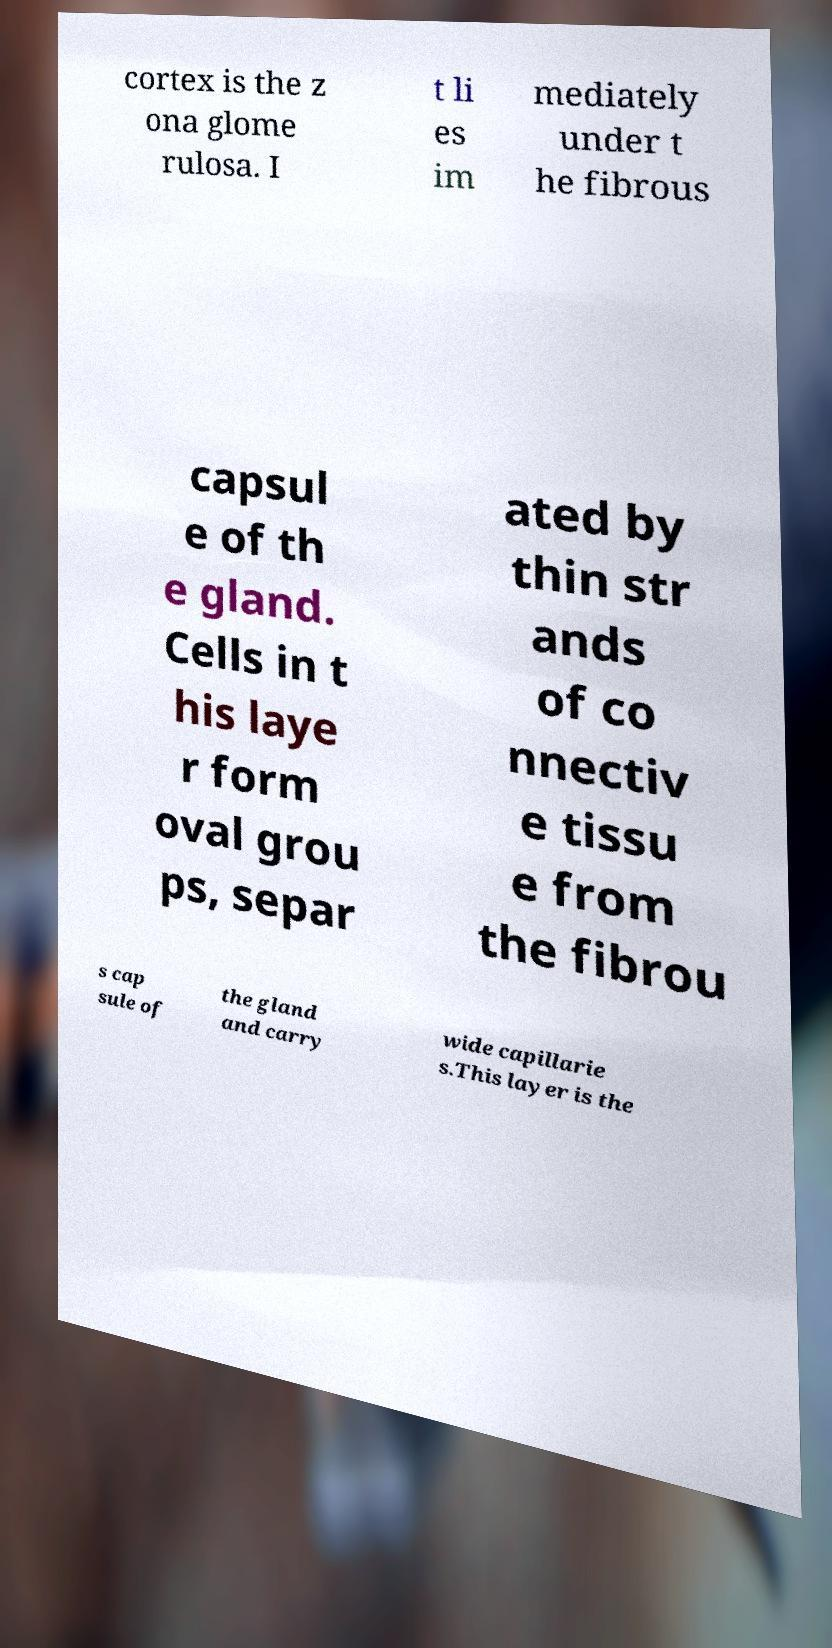There's text embedded in this image that I need extracted. Can you transcribe it verbatim? cortex is the z ona glome rulosa. I t li es im mediately under t he fibrous capsul e of th e gland. Cells in t his laye r form oval grou ps, separ ated by thin str ands of co nnectiv e tissu e from the fibrou s cap sule of the gland and carry wide capillarie s.This layer is the 